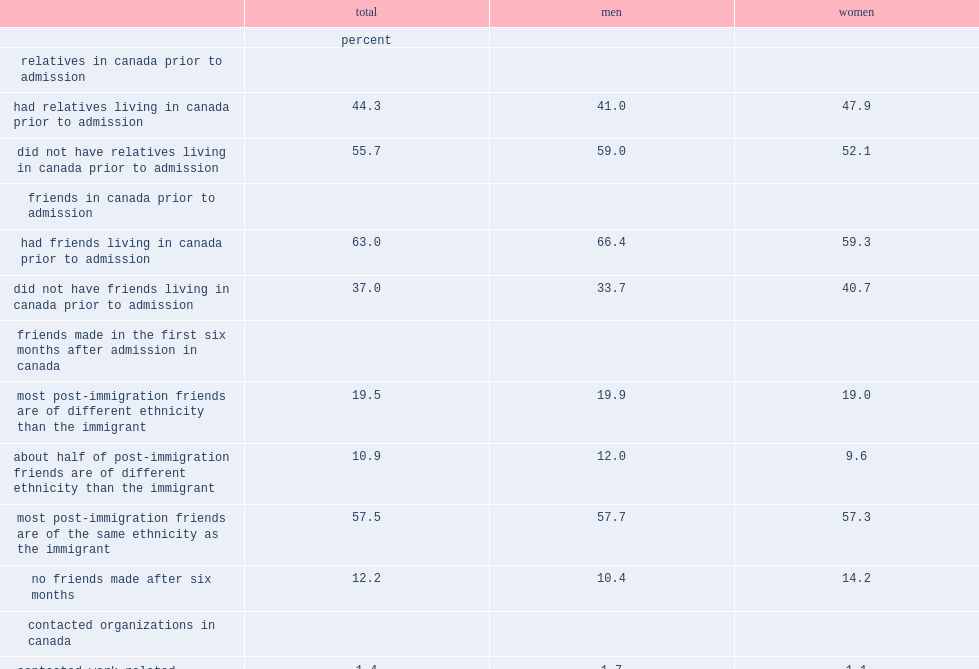What is the percentage of immigrants had relatives in the country prior to their admission? 44.3. What is the percentage of immigrants had friends in the country prior to admission? 63.0. Which sex was more likely to have relatives who were living in the country prior to their admission in 2001? Women. Which sex was less likely to have pre-admission friends ? Women. What is the percentage of immigrants who were admitted in 2001 reported that the friends they made after they were admitted to canada were mostly from their own ethnic group? 57.5. What is the percentage of immigrants reported that most of the friends they made after migrating to canada were from outside their ethnic group? 19.5. What is the percentage of immigrants reported that their post-immigration friends were equally divided between those who were from the same ethnic group and those who were from other ethnic groups? 10.9. What is the percentage of immigrants reported that they did not make any friends in their first six months after admission? 12.2. 